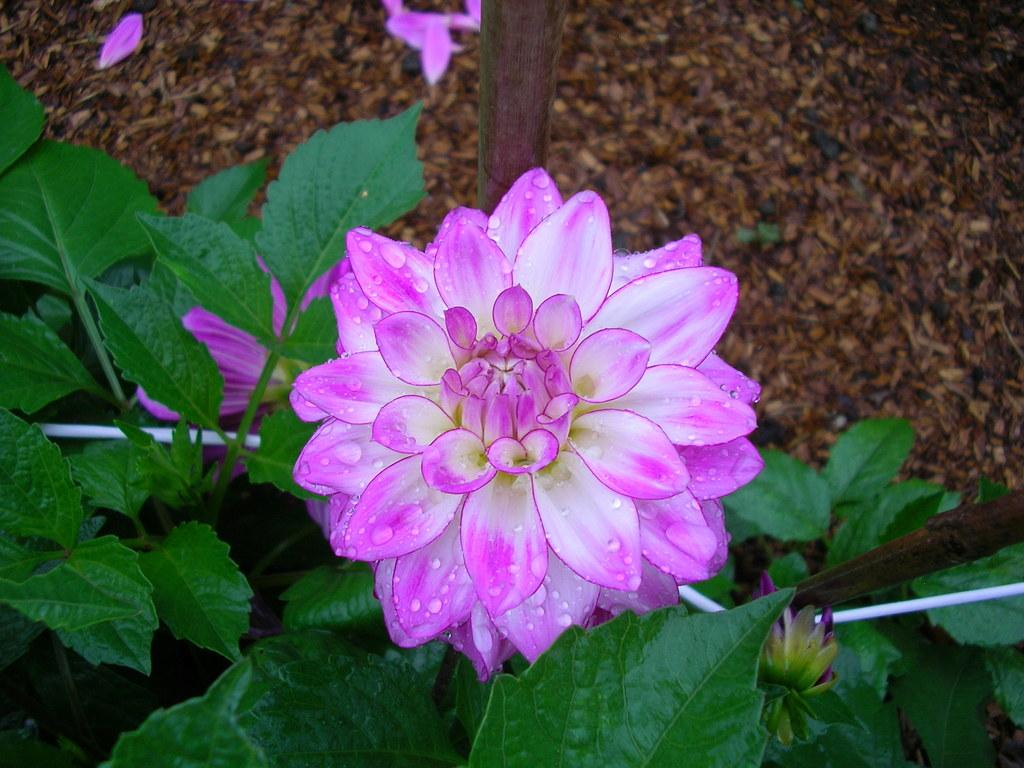What is the main subject in the foreground of the image? There is a pink color flower in the foreground of the image. What is the relationship between the flower and the plant? The flower is attached to a plant. What can be seen in the background of the image? There is a flower and a pole in the background of the image, as well as the ground. What type of nail is being used to hold the flower in place in the image? There is no nail present in the image; the flower is attached to the plant naturally. 